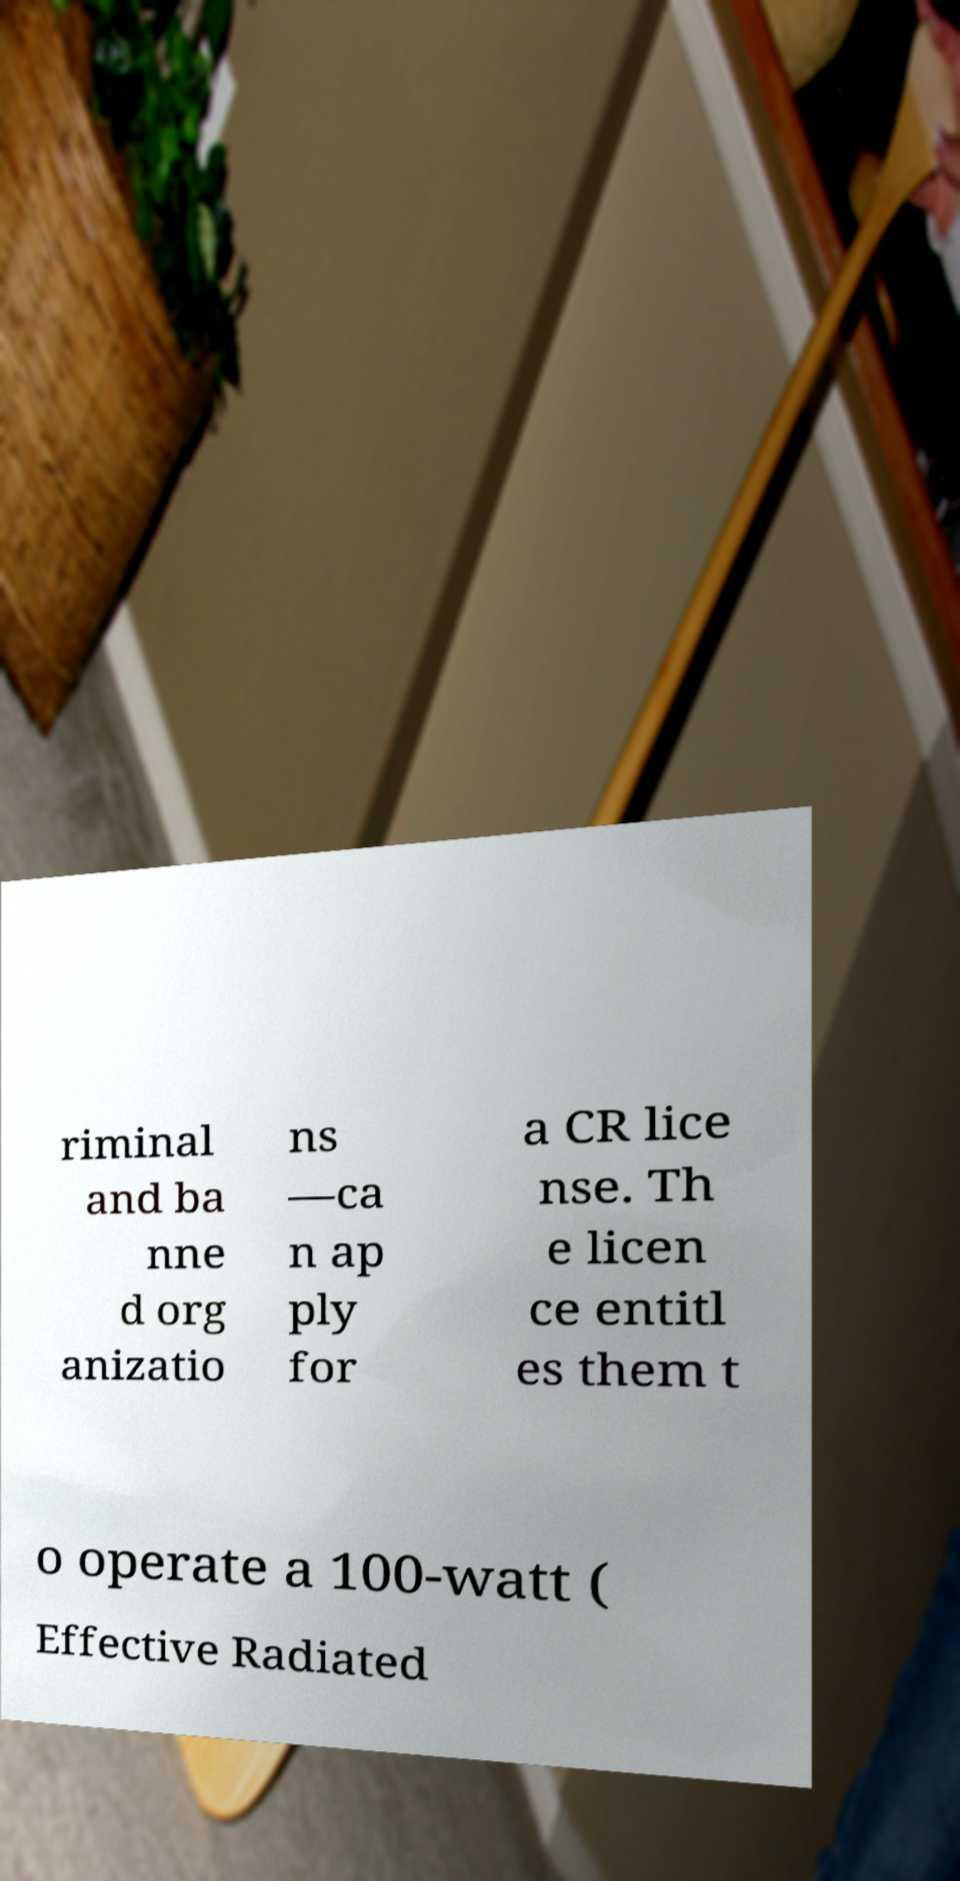There's text embedded in this image that I need extracted. Can you transcribe it verbatim? riminal and ba nne d org anizatio ns —ca n ap ply for a CR lice nse. Th e licen ce entitl es them t o operate a 100-watt ( Effective Radiated 